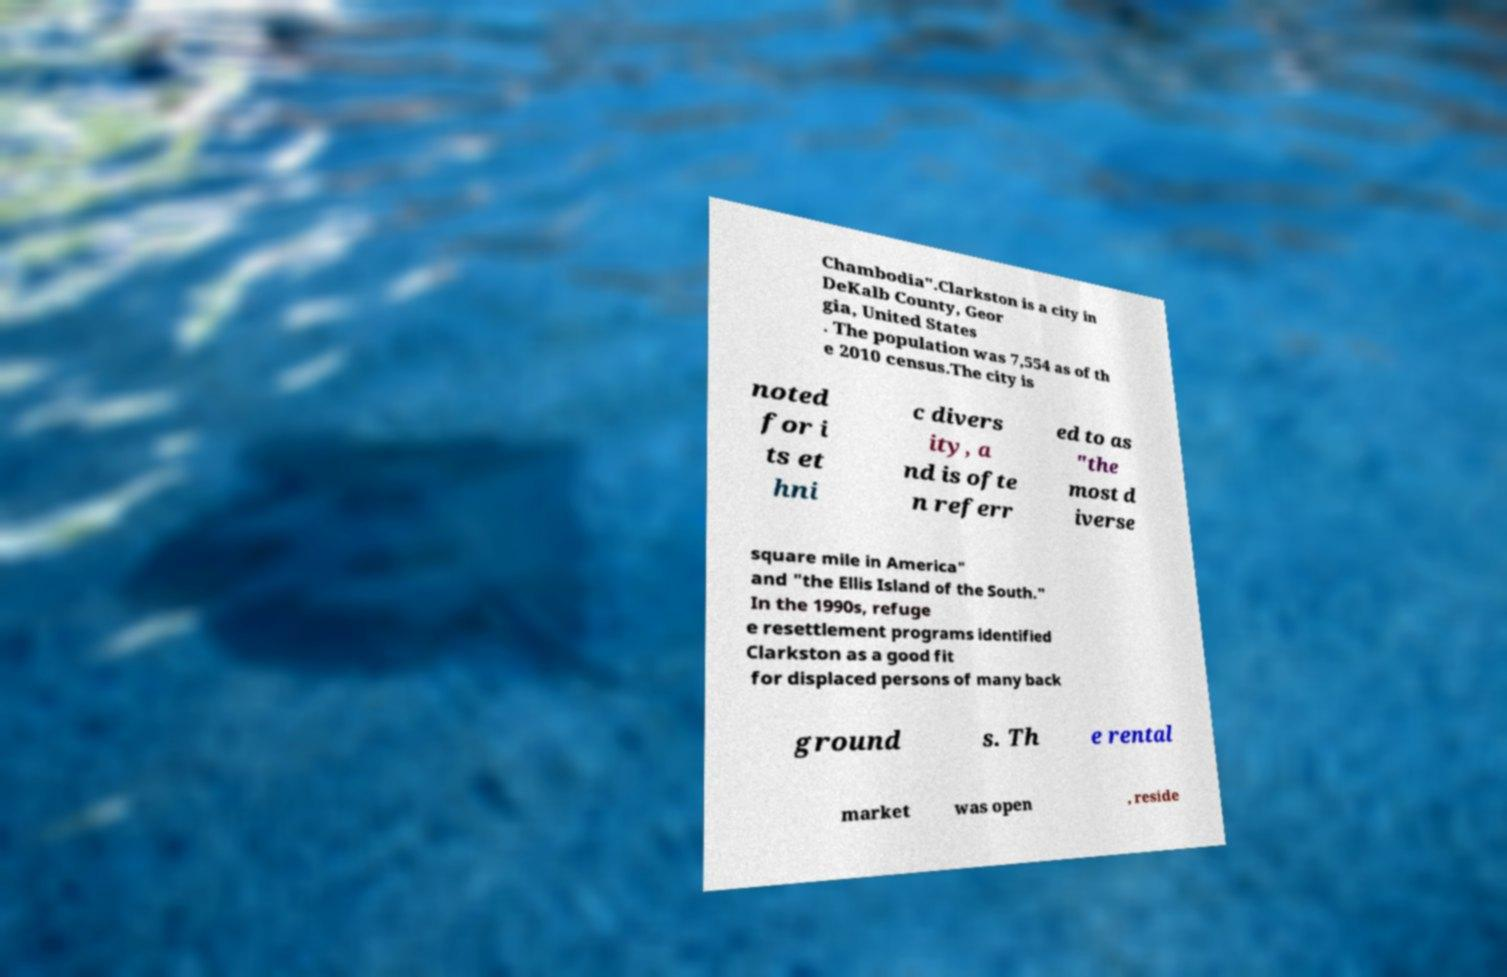Please identify and transcribe the text found in this image. Chambodia".Clarkston is a city in DeKalb County, Geor gia, United States . The population was 7,554 as of th e 2010 census.The city is noted for i ts et hni c divers ity, a nd is ofte n referr ed to as "the most d iverse square mile in America" and "the Ellis Island of the South." In the 1990s, refuge e resettlement programs identified Clarkston as a good fit for displaced persons of many back ground s. Th e rental market was open , reside 